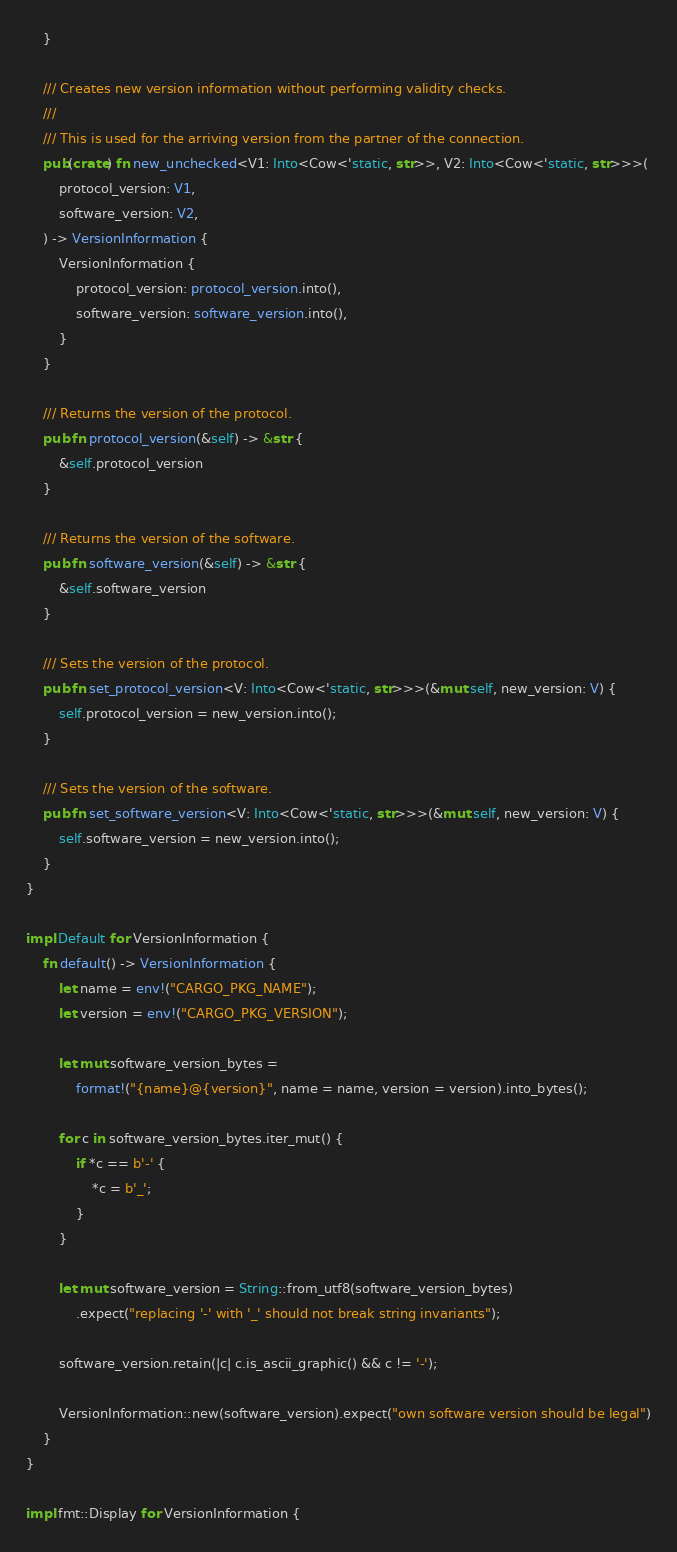Convert code to text. <code><loc_0><loc_0><loc_500><loc_500><_Rust_>    }

    /// Creates new version information without performing validity checks.
    ///
    /// This is used for the arriving version from the partner of the connection.
    pub(crate) fn new_unchecked<V1: Into<Cow<'static, str>>, V2: Into<Cow<'static, str>>>(
        protocol_version: V1,
        software_version: V2,
    ) -> VersionInformation {
        VersionInformation {
            protocol_version: protocol_version.into(),
            software_version: software_version.into(),
        }
    }

    /// Returns the version of the protocol.
    pub fn protocol_version(&self) -> &str {
        &self.protocol_version
    }

    /// Returns the version of the software.
    pub fn software_version(&self) -> &str {
        &self.software_version
    }

    /// Sets the version of the protocol.
    pub fn set_protocol_version<V: Into<Cow<'static, str>>>(&mut self, new_version: V) {
        self.protocol_version = new_version.into();
    }

    /// Sets the version of the software.
    pub fn set_software_version<V: Into<Cow<'static, str>>>(&mut self, new_version: V) {
        self.software_version = new_version.into();
    }
}

impl Default for VersionInformation {
    fn default() -> VersionInformation {
        let name = env!("CARGO_PKG_NAME");
        let version = env!("CARGO_PKG_VERSION");

        let mut software_version_bytes =
            format!("{name}@{version}", name = name, version = version).into_bytes();

        for c in software_version_bytes.iter_mut() {
            if *c == b'-' {
                *c = b'_';
            }
        }

        let mut software_version = String::from_utf8(software_version_bytes)
            .expect("replacing '-' with '_' should not break string invariants");

        software_version.retain(|c| c.is_ascii_graphic() && c != '-');

        VersionInformation::new(software_version).expect("own software version should be legal")
    }
}

impl fmt::Display for VersionInformation {</code> 